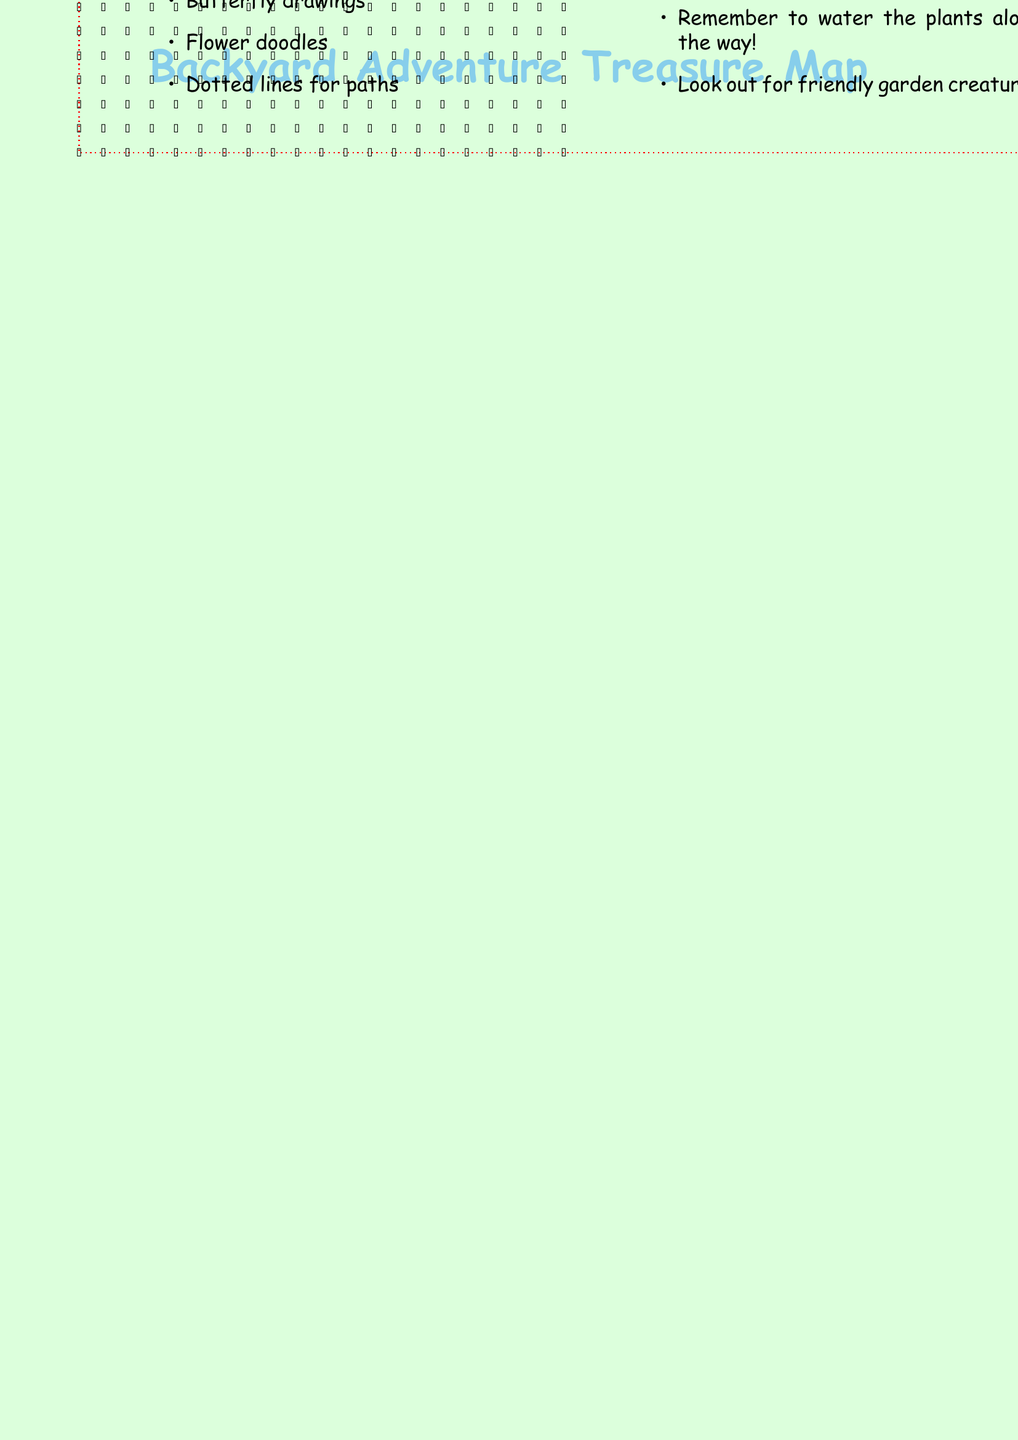What is the starting point of the treasure map? The starting point is listed in the document, indicating the location from where the adventure begins.
Answer: Patio How many clues are provided in the document? The clues section lists the number of clues that should be followed during the adventure.
Answer: 4 Where is the secret garden located? The document specifies the exact location of the secret garden relevant to the treasure hunt.
Answer: Behind the rose trellis What treasure is hidden in the garden? The treasure section describes what participants can find upon reaching the secret location.
Answer: A small wooden box filled with colorful garden seeds and a new pair of child-sized gardening gloves What are two landmarks mentioned in the map? The landmarks section lists various features that will help navigate the backyard during the adventure.
Answer: Oak Tree, Bird Bath How do you reach the first clue? The first clue outlines an action based on the details given in the clues section.
Answer: Follow the pawprints What should you look for under the leaves? The clues inform participants what specific item to search for during the adventure.
Answer: A shiny object What are two types of paths mentioned in the document? The paths section details the various routes that can be taken as part of the garden adventure.
Answer: Stepping Stones, Winding Dirt Trail What should you remember to do along the way? The special notes provide guidance for maintaining the garden during the adventure.
Answer: Water the plants 